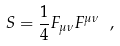<formula> <loc_0><loc_0><loc_500><loc_500>S = \frac { 1 } { 4 } F _ { \mu \nu } F ^ { \mu \nu } \ ,</formula> 